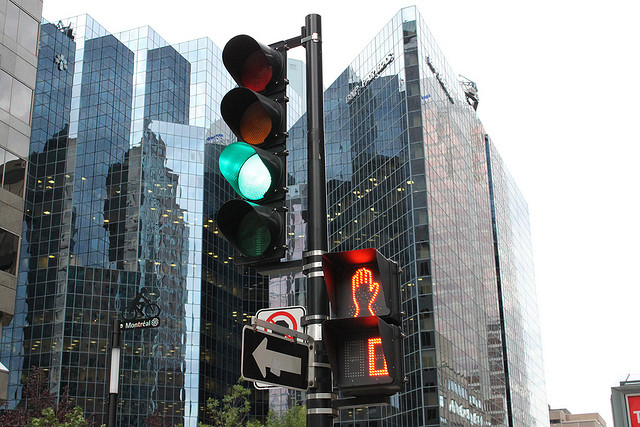How many traffic lights are pictured? There is one traffic signal visible in the image, which includes a set of three lights typically used to control vehicular traffic, showing green, yellow, and red lights from top to bottom. 